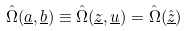<formula> <loc_0><loc_0><loc_500><loc_500>\hat { \Omega } ( \underline { a } , \underline { b } ) \equiv \hat { \Omega } ( \underline { z } , \underline { u } ) = \hat { \Omega } ( \hat { \underline { z } } )</formula> 